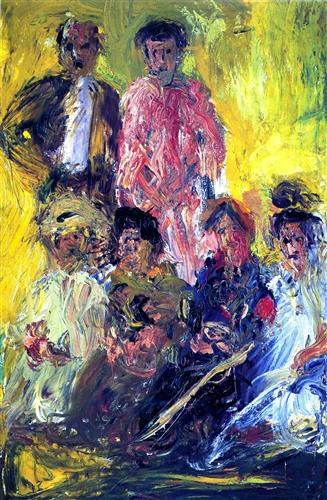What feelings does this painting evoke? The painting evokes a sense of joy and energy through its vibrant color palette and expressive brushstrokes. The figures appear engaged with one another, suggesting feelings of camaraderie and connection. The nuances of the rough textures and bold color contrasts may also convey a sense of raw emotion, possibly reflecting the artist's personal feelings or a particular social atmosphere. 